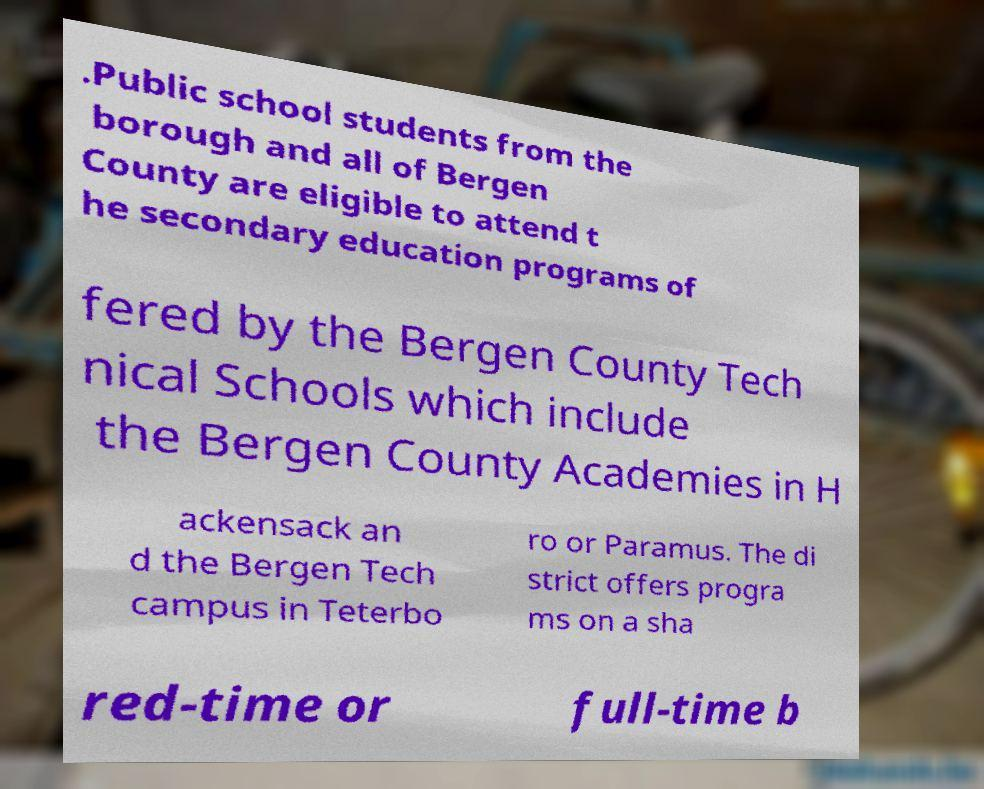Please read and relay the text visible in this image. What does it say? .Public school students from the borough and all of Bergen County are eligible to attend t he secondary education programs of fered by the Bergen County Tech nical Schools which include the Bergen County Academies in H ackensack an d the Bergen Tech campus in Teterbo ro or Paramus. The di strict offers progra ms on a sha red-time or full-time b 